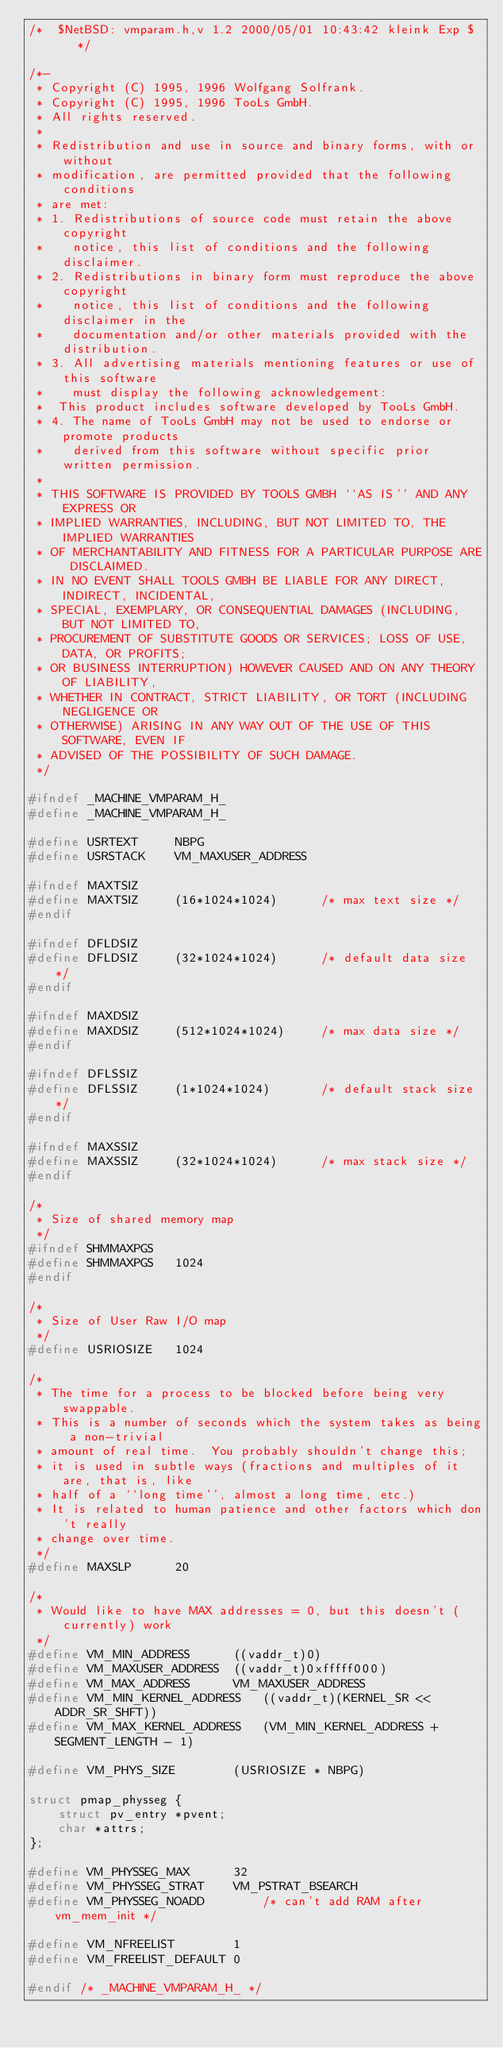<code> <loc_0><loc_0><loc_500><loc_500><_C_>/*	$NetBSD: vmparam.h,v 1.2 2000/05/01 10:43:42 kleink Exp $	*/

/*-
 * Copyright (C) 1995, 1996 Wolfgang Solfrank.
 * Copyright (C) 1995, 1996 TooLs GmbH.
 * All rights reserved.
 *
 * Redistribution and use in source and binary forms, with or without
 * modification, are permitted provided that the following conditions
 * are met:
 * 1. Redistributions of source code must retain the above copyright
 *    notice, this list of conditions and the following disclaimer.
 * 2. Redistributions in binary form must reproduce the above copyright
 *    notice, this list of conditions and the following disclaimer in the
 *    documentation and/or other materials provided with the distribution.
 * 3. All advertising materials mentioning features or use of this software
 *    must display the following acknowledgement:
 *	This product includes software developed by TooLs GmbH.
 * 4. The name of TooLs GmbH may not be used to endorse or promote products
 *    derived from this software without specific prior written permission.
 *
 * THIS SOFTWARE IS PROVIDED BY TOOLS GMBH ``AS IS'' AND ANY EXPRESS OR
 * IMPLIED WARRANTIES, INCLUDING, BUT NOT LIMITED TO, THE IMPLIED WARRANTIES
 * OF MERCHANTABILITY AND FITNESS FOR A PARTICULAR PURPOSE ARE DISCLAIMED.
 * IN NO EVENT SHALL TOOLS GMBH BE LIABLE FOR ANY DIRECT, INDIRECT, INCIDENTAL,
 * SPECIAL, EXEMPLARY, OR CONSEQUENTIAL DAMAGES (INCLUDING, BUT NOT LIMITED TO,
 * PROCUREMENT OF SUBSTITUTE GOODS OR SERVICES; LOSS OF USE, DATA, OR PROFITS;
 * OR BUSINESS INTERRUPTION) HOWEVER CAUSED AND ON ANY THEORY OF LIABILITY,
 * WHETHER IN CONTRACT, STRICT LIABILITY, OR TORT (INCLUDING NEGLIGENCE OR
 * OTHERWISE) ARISING IN ANY WAY OUT OF THE USE OF THIS SOFTWARE, EVEN IF
 * ADVISED OF THE POSSIBILITY OF SUCH DAMAGE.
 */

#ifndef	_MACHINE_VMPARAM_H_
#define	_MACHINE_VMPARAM_H_

#define	USRTEXT		NBPG
#define	USRSTACK	VM_MAXUSER_ADDRESS

#ifndef	MAXTSIZ
#define	MAXTSIZ		(16*1024*1024)		/* max text size */
#endif

#ifndef	DFLDSIZ
#define	DFLDSIZ		(32*1024*1024)		/* default data size */
#endif

#ifndef	MAXDSIZ
#define	MAXDSIZ		(512*1024*1024)		/* max data size */
#endif

#ifndef	DFLSSIZ
#define	DFLSSIZ		(1*1024*1024)		/* default stack size */
#endif

#ifndef	MAXSSIZ
#define	MAXSSIZ		(32*1024*1024)		/* max stack size */
#endif

/*
 * Size of shared memory map
 */
#ifndef	SHMMAXPGS
#define	SHMMAXPGS	1024
#endif

/*
 * Size of User Raw I/O map
 */
#define	USRIOSIZE	1024

/*
 * The time for a process to be blocked before being very swappable.
 * This is a number of seconds which the system takes as being a non-trivial
 * amount of real time.  You probably shouldn't change this;
 * it is used in subtle ways (fractions and multiples of it are, that is, like
 * half of a ``long time'', almost a long time, etc.)
 * It is related to human patience and other factors which don't really
 * change over time.
 */
#define	MAXSLP 		20

/*
 * Would like to have MAX addresses = 0, but this doesn't (currently) work
 */
#define	VM_MIN_ADDRESS		((vaddr_t)0)
#define	VM_MAXUSER_ADDRESS	((vaddr_t)0xfffff000)
#define	VM_MAX_ADDRESS		VM_MAXUSER_ADDRESS
#define	VM_MIN_KERNEL_ADDRESS	((vaddr_t)(KERNEL_SR << ADDR_SR_SHFT))
#define	VM_MAX_KERNEL_ADDRESS	(VM_MIN_KERNEL_ADDRESS + SEGMENT_LENGTH - 1)

#define	VM_PHYS_SIZE		(USRIOSIZE * NBPG)

struct pmap_physseg {
	struct pv_entry *pvent;
	char *attrs;
};

#define VM_PHYSSEG_MAX		32
#define VM_PHYSSEG_STRAT	VM_PSTRAT_BSEARCH
#define VM_PHYSSEG_NOADD		/* can't add RAM after vm_mem_init */

#define VM_NFREELIST		1
#define VM_FREELIST_DEFAULT	0

#endif /* _MACHINE_VMPARAM_H_ */
</code> 